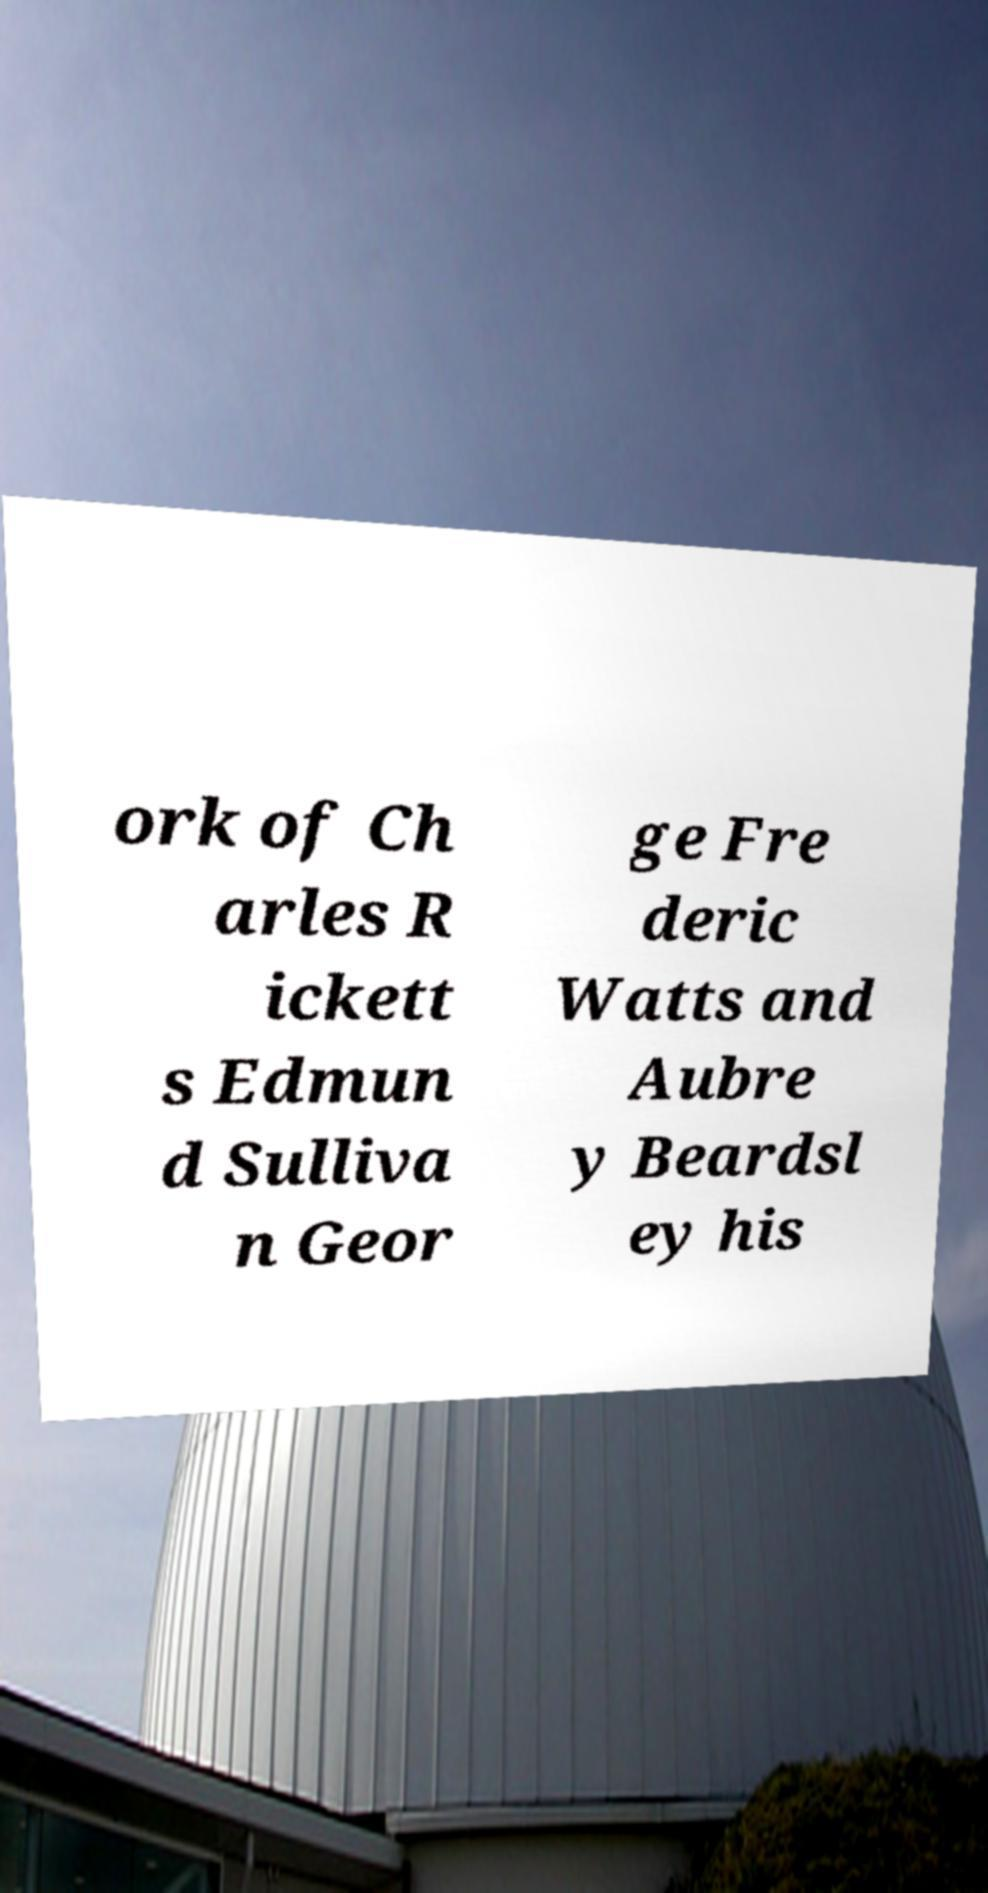Please identify and transcribe the text found in this image. ork of Ch arles R ickett s Edmun d Sulliva n Geor ge Fre deric Watts and Aubre y Beardsl ey his 